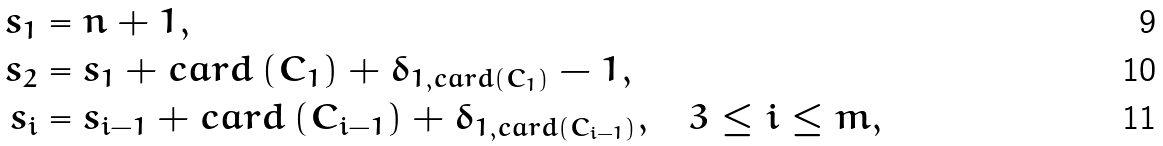Convert formula to latex. <formula><loc_0><loc_0><loc_500><loc_500>s _ { 1 } & = n + 1 , \\ s _ { 2 } & = s _ { 1 } + c a r d \left ( C _ { 1 } \right ) + \delta _ { 1 , c a r d \left ( C _ { 1 } \right ) } - 1 , \\ s _ { i } & = s _ { i - 1 } + c a r d \left ( C _ { i - 1 } \right ) + \delta _ { 1 , c a r d \left ( C _ { i - 1 } \right ) } , \text { \ \ } 3 \leq i \leq m ,</formula> 